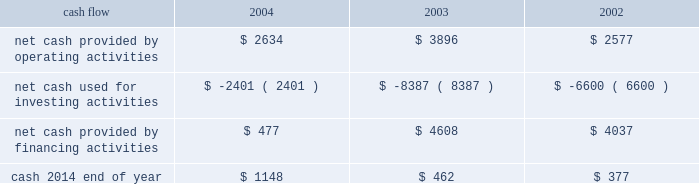On october 21 , 2004 , the hartford declared a dividend on its common stock of $ 0.29 per share payable on january 3 , 2005 to shareholders of record as of december 1 , 2004 .
The hartford declared $ 331 and paid $ 325 in dividends to shareholders in 2004 , declared $ 300 and paid $ 291 in dividends to shareholders in 2003 , declared $ 262 and paid $ 257 in 2002 .
Aoci - aoci increased by $ 179 as of december 31 , 2004 compared with december 31 , 2003 .
The increase in aoci is primarily the result of life 2019s adoption of sop 03-1 , which resulted in a $ 292 cumulative effect for unrealized gains on securities in the first quarter of 2004 related to the reclassification of investments from separate account assets to general account assets , partially offset by net unrealized losses on cash-flow hedging instruments .
The funded status of the company 2019s pension and postretirement plans is dependent upon many factors , including returns on invested assets and the level of market interest rates .
Declines in the value of securities traded in equity markets coupled with declines in long- term interest rates have had a negative impact on the funded status of the plans .
As a result , the company recorded a minimum pension liability as of december 31 , 2004 , and 2003 , which resulted in an after-tax reduction of stockholders 2019 equity of $ 480 and $ 375 respectively .
This minimum pension liability did not affect the company 2019s results of operations .
For additional information on stockholders 2019 equity and aoci see notes 15 and 16 , respectively , of notes to consolidated financial statements .
Cash flow 2004 2003 2002 .
2004 compared to 2003 2014 cash from operating activities primarily reflects premium cash flows in excess of claim payments .
The decrease in cash provided by operating activities was due primarily to the $ 1.15 billion settlement of the macarthur litigation in 2004 .
Cash provided by financing activities decreased primarily due to lower proceeds from investment and universal life-type contracts as a result of the adoption of sop 03-1 , decreased capital raising activities , repayment of commercial paper and early retirement of junior subordinated debentures in 2004 .
The decrease in cash from financing activities and operating cash flows invested long-term accounted for the majority of the change in cash used for investing activities .
2003 compared to 2002 2014 the increase in cash provided by operating activities was primarily the result of strong premium cash flows .
Financing activities increased primarily due to capital raising activities related to the 2003 asbestos reserve addition and decreased due to repayments on long-term debt and lower proceeds from investment and universal life-type contracts .
The increase in cash from financing activities accounted for the majority of the change in cash used for investing activities .
Operating cash flows in each of the last three years have been adequate to meet liquidity requirements .
Equity markets for a discussion of the potential impact of the equity markets on capital and liquidity , see the capital markets risk management section under 201cmarket risk 201d .
Ratings ratings are an important factor in establishing the competitive position in the insurance and financial services marketplace .
There can be no assurance that the company's ratings will continue for any given period of time or that they will not be changed .
In the event the company's ratings are downgraded , the level of revenues or the persistency of the company's business may be adversely impacted .
On august 4 , 2004 , moody 2019s affirmed the company 2019s and hartford life , inc . 2019s a3 senior debt ratings as well as the aa3 insurance financial strength ratings of both its property-casualty and life insurance operating subsidiaries .
In addition , moody 2019s changed the outlook for all of these ratings from negative to stable .
Since the announcement of the suit filed by the new york attorney general 2019s office against marsh & mclennan companies , inc. , and marsh , inc .
On october 14 , 2004 , the major independent ratings agencies have indicated that they continue to monitor developments relating to the suit .
On october 22 , 2004 , standard & poor 2019s revised its outlook on the u.s .
Property/casualty commercial lines sector to negative from stable .
On november 23 , 2004 , standard & poor 2019s revised its outlook on the financial strength and credit ratings of the property-casualty insurance subsidiaries to negative from stable .
The outlook on the life insurance subsidiaries and corporate debt was unaffected. .
In 2004 what was the percent of the hartford declared dividends that was paid to shareholders i? 
Computations: (325 / 331)
Answer: 0.98187. 